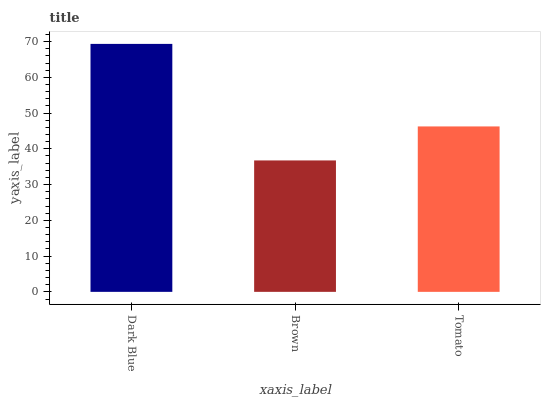Is Brown the minimum?
Answer yes or no. Yes. Is Dark Blue the maximum?
Answer yes or no. Yes. Is Tomato the minimum?
Answer yes or no. No. Is Tomato the maximum?
Answer yes or no. No. Is Tomato greater than Brown?
Answer yes or no. Yes. Is Brown less than Tomato?
Answer yes or no. Yes. Is Brown greater than Tomato?
Answer yes or no. No. Is Tomato less than Brown?
Answer yes or no. No. Is Tomato the high median?
Answer yes or no. Yes. Is Tomato the low median?
Answer yes or no. Yes. Is Dark Blue the high median?
Answer yes or no. No. Is Dark Blue the low median?
Answer yes or no. No. 